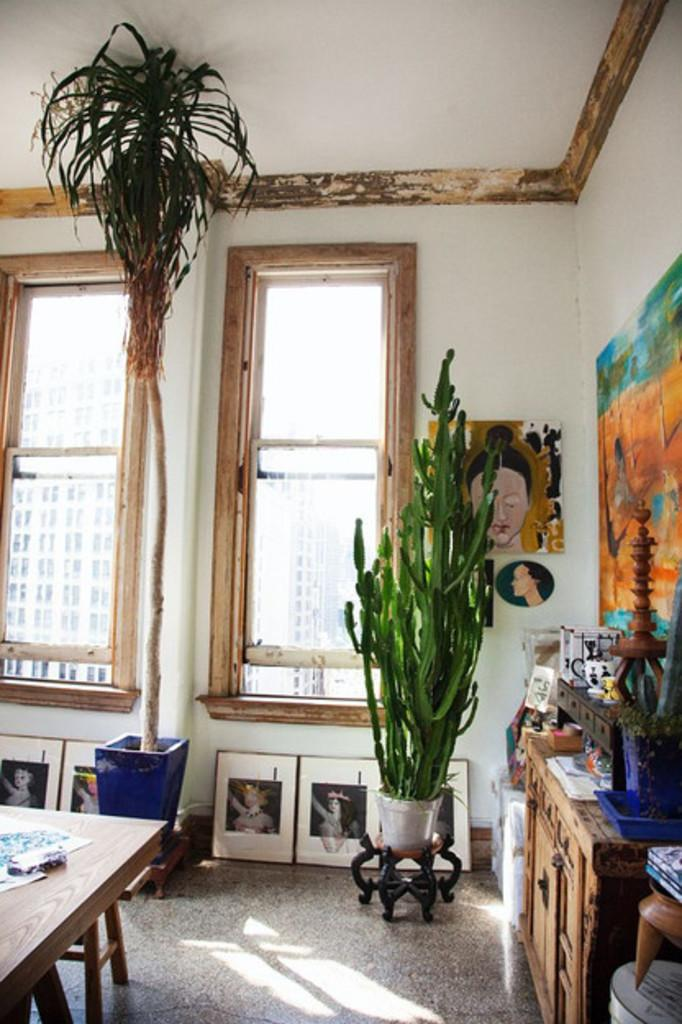How many plants can be seen in the image? There are 2 plants in the image. What can be seen through the windows in the image? The presence of windows suggests that there is a view outside, but the specifics are not mentioned in the facts. What type of decoration is on the wall in the image? There is art on the wall in the image. What type of furniture is present in the image? There is a cupboard and a table in the image. What items can be seen on the cupboard? Photo frames are on the cupboard in the image. What type of reason can be seen on the table in the image? There is no mention of a reason in the image; the table contains a bowl of ice cream, sweets, plastic spoons, a mobile, and napkins. What type of brake is present on the plants in the image? There are no brakes present on the plants in the image; they are simply plants. 